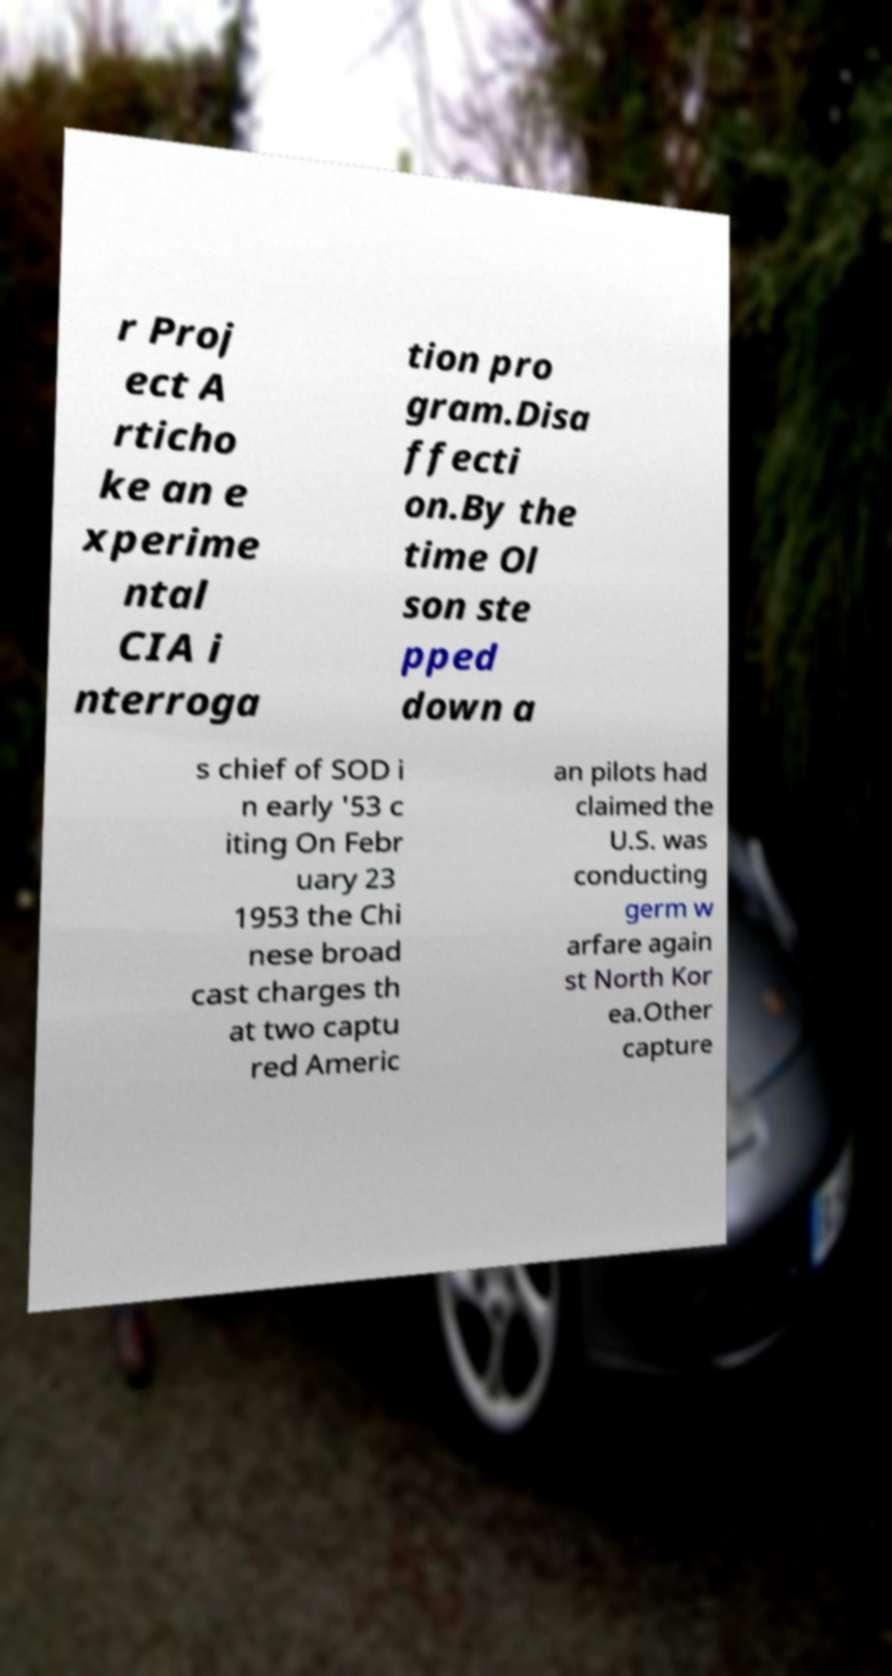Please read and relay the text visible in this image. What does it say? r Proj ect A rticho ke an e xperime ntal CIA i nterroga tion pro gram.Disa ffecti on.By the time Ol son ste pped down a s chief of SOD i n early '53 c iting On Febr uary 23 1953 the Chi nese broad cast charges th at two captu red Americ an pilots had claimed the U.S. was conducting germ w arfare again st North Kor ea.Other capture 